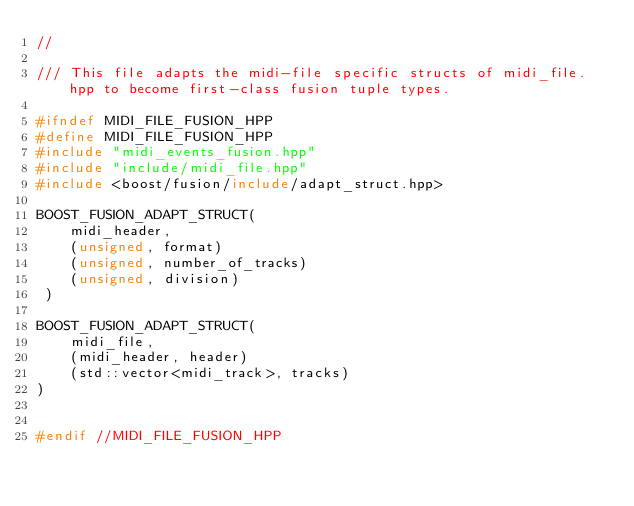Convert code to text. <code><loc_0><loc_0><loc_500><loc_500><_C++_>//

/// This file adapts the midi-file specific structs of midi_file.hpp to become first-class fusion tuple types.

#ifndef MIDI_FILE_FUSION_HPP
#define MIDI_FILE_FUSION_HPP
#include "midi_events_fusion.hpp"
#include "include/midi_file.hpp"
#include <boost/fusion/include/adapt_struct.hpp>

BOOST_FUSION_ADAPT_STRUCT(
    midi_header,
    (unsigned, format)
    (unsigned, number_of_tracks)
    (unsigned, division)
 )

BOOST_FUSION_ADAPT_STRUCT(
    midi_file,
    (midi_header, header)
    (std::vector<midi_track>, tracks)
)


#endif //MIDI_FILE_FUSION_HPP
</code> 